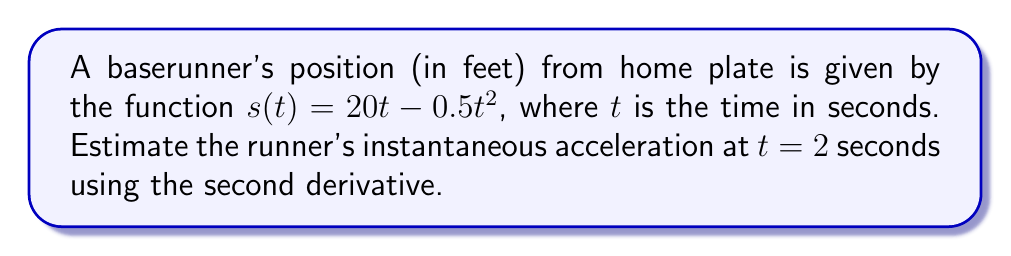Could you help me with this problem? To estimate the instantaneous acceleration, we need to find the second derivative of the position function.

Step 1: Find the first derivative (velocity function)
The first derivative represents the velocity of the runner.
$$\frac{d}{dt}s(t) = s'(t) = 20 - t$$

Step 2: Find the second derivative (acceleration function)
The second derivative represents the acceleration of the runner.
$$\frac{d}{dt}s'(t) = s''(t) = -1$$

Step 3: Evaluate the second derivative at $t = 2$
Since the second derivative is a constant, the acceleration is the same at all times, including $t = 2$.
$$s''(2) = -1$$

The negative value indicates that the runner is decelerating. In baseball terms, this could represent a runner slowing down as they approach a base.
Answer: $-1$ ft/s² 